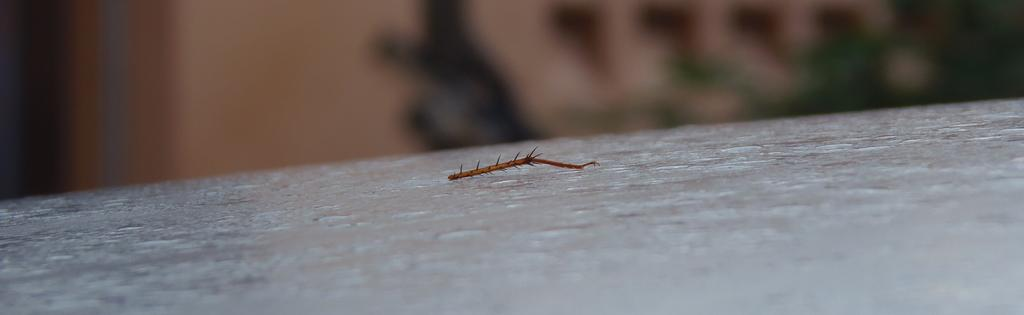What objects can be seen on the road in the image? There are dried stems on the road in the image. Can you describe the background of the image? The background of the image is blurred. What type of bushes can be seen growing along the border in the image? There are no bushes or borders present in the image; it only features dried stems on the road and a blurred background. 